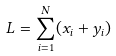<formula> <loc_0><loc_0><loc_500><loc_500>L = \sum _ { i = 1 } ^ { N } ( x _ { i } + y _ { i } )</formula> 